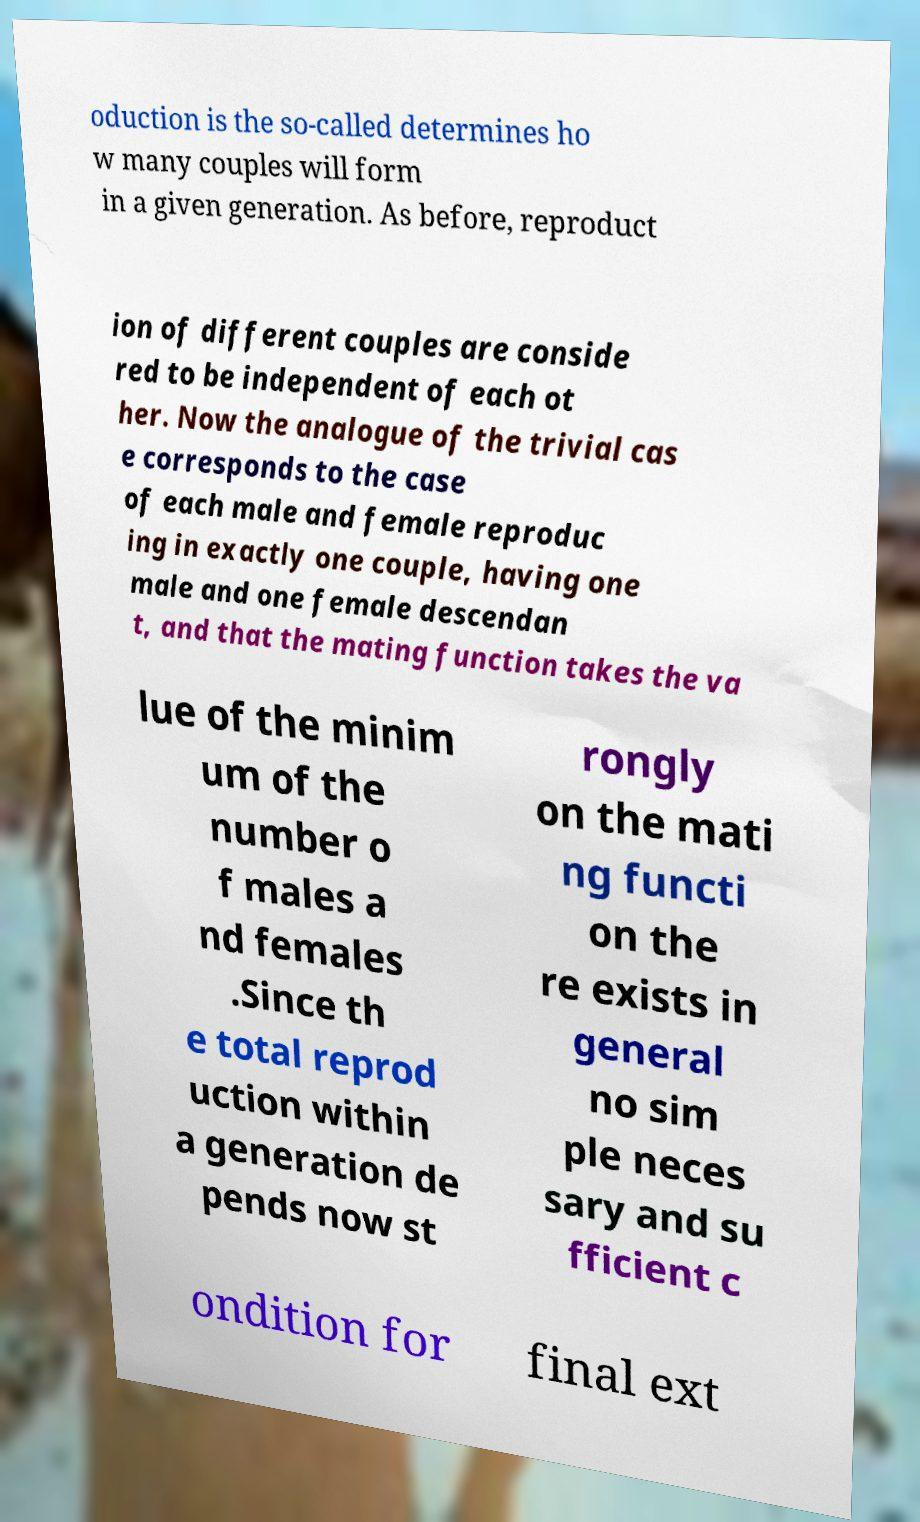Can you accurately transcribe the text from the provided image for me? oduction is the so-called determines ho w many couples will form in a given generation. As before, reproduct ion of different couples are conside red to be independent of each ot her. Now the analogue of the trivial cas e corresponds to the case of each male and female reproduc ing in exactly one couple, having one male and one female descendan t, and that the mating function takes the va lue of the minim um of the number o f males a nd females .Since th e total reprod uction within a generation de pends now st rongly on the mati ng functi on the re exists in general no sim ple neces sary and su fficient c ondition for final ext 